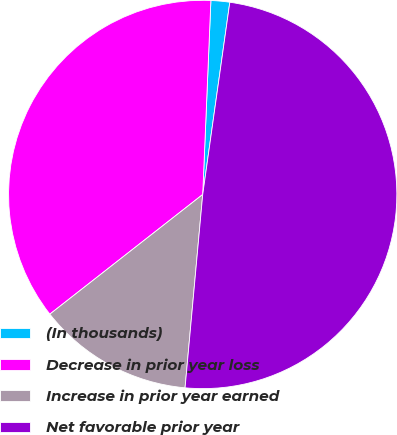Convert chart. <chart><loc_0><loc_0><loc_500><loc_500><pie_chart><fcel>(In thousands)<fcel>Decrease in prior year loss<fcel>Increase in prior year earned<fcel>Net favorable prior year<nl><fcel>1.56%<fcel>36.24%<fcel>12.98%<fcel>49.22%<nl></chart> 